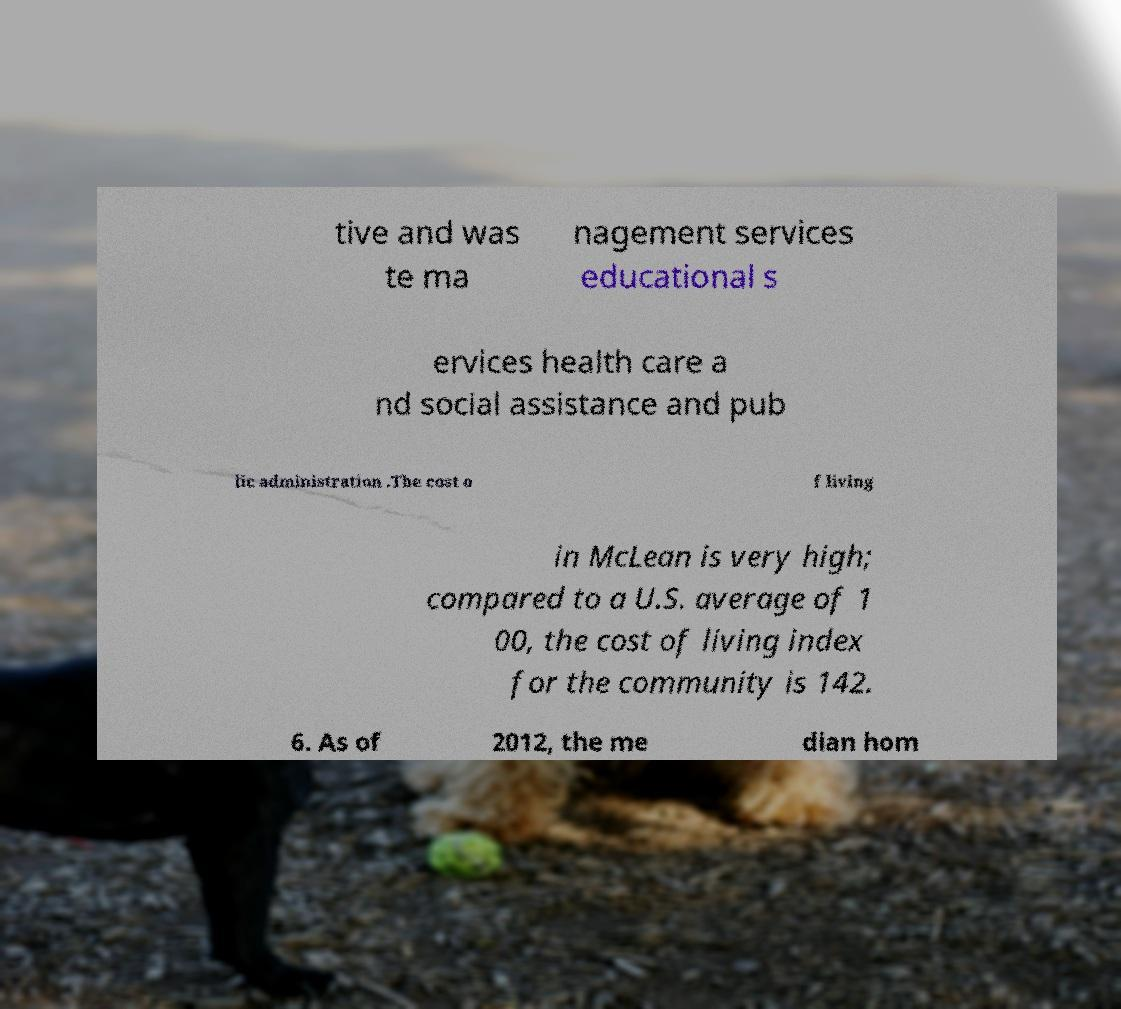There's text embedded in this image that I need extracted. Can you transcribe it verbatim? tive and was te ma nagement services educational s ervices health care a nd social assistance and pub lic administration .The cost o f living in McLean is very high; compared to a U.S. average of 1 00, the cost of living index for the community is 142. 6. As of 2012, the me dian hom 